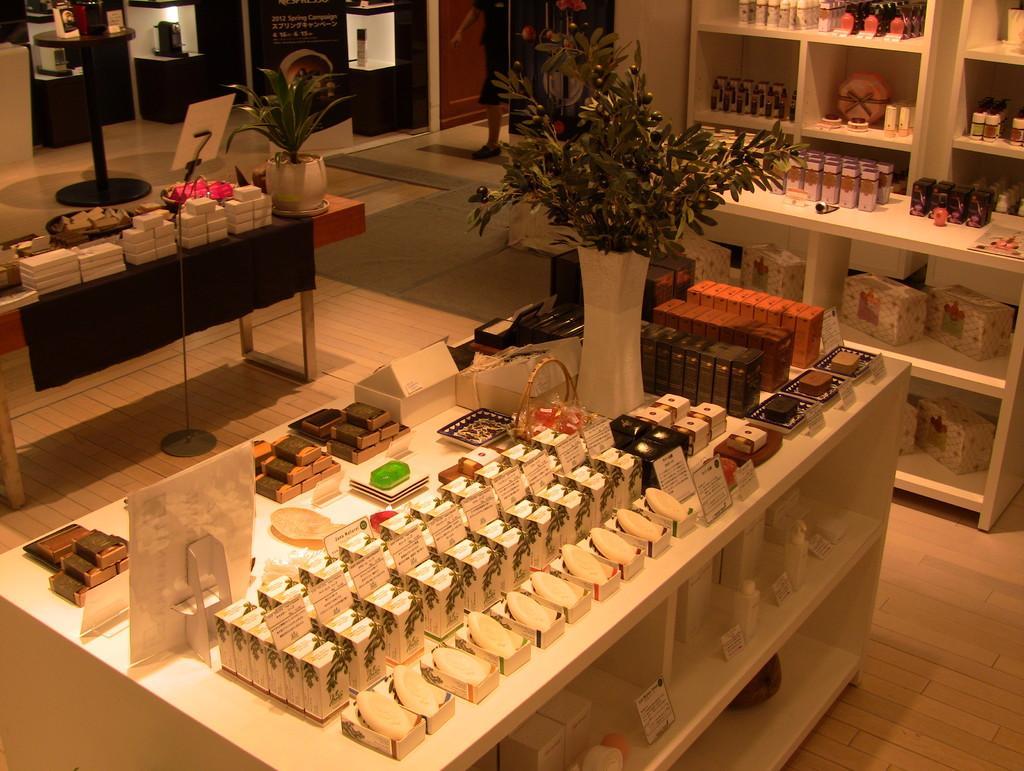Could you give a brief overview of what you see in this image? In this image I can see the table. On the table I can see the board, flower vase and many boxes. To the left I can see one more table with objects and the flower pot on it. To the right there is a rack with many objects. In the background I can see the person with the black color dress and the boards. 